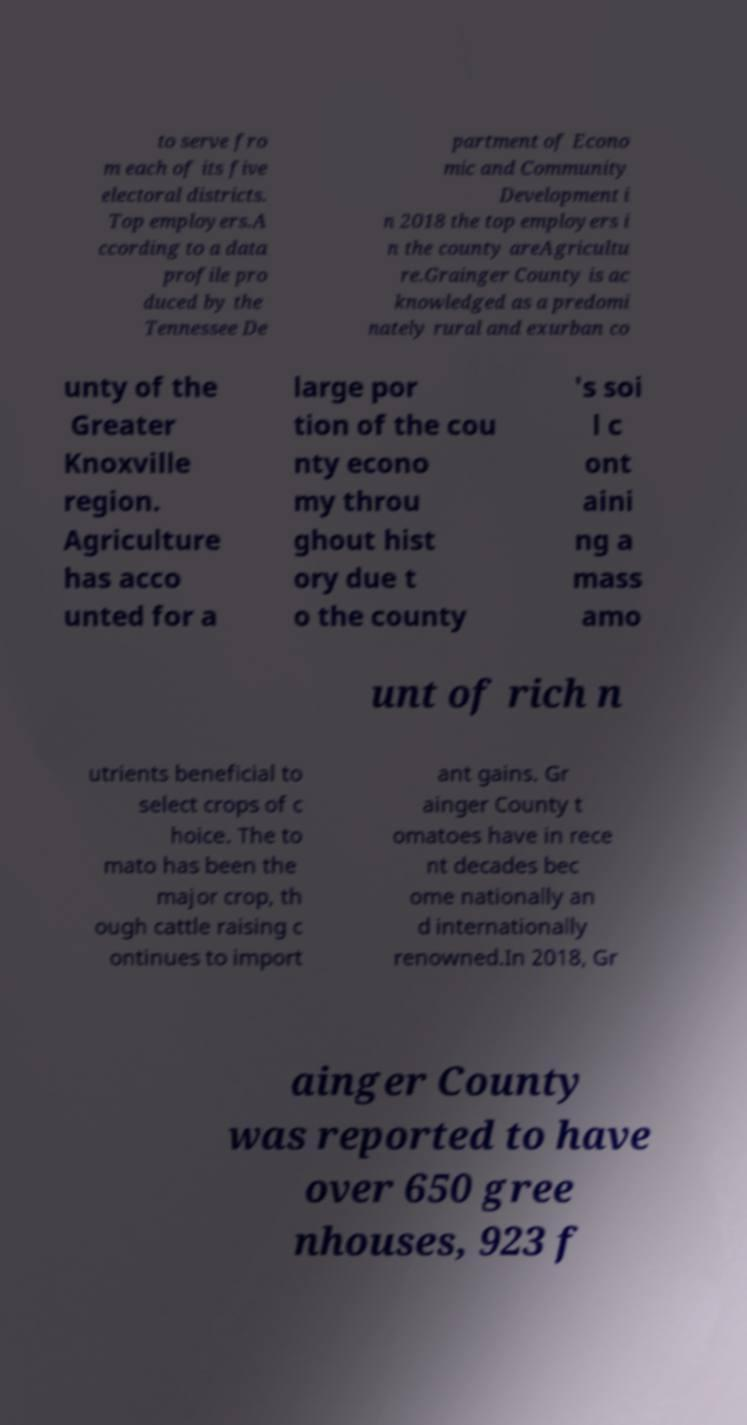For documentation purposes, I need the text within this image transcribed. Could you provide that? to serve fro m each of its five electoral districts. Top employers.A ccording to a data profile pro duced by the Tennessee De partment of Econo mic and Community Development i n 2018 the top employers i n the county areAgricultu re.Grainger County is ac knowledged as a predomi nately rural and exurban co unty of the Greater Knoxville region. Agriculture has acco unted for a large por tion of the cou nty econo my throu ghout hist ory due t o the county 's soi l c ont aini ng a mass amo unt of rich n utrients beneficial to select crops of c hoice. The to mato has been the major crop, th ough cattle raising c ontinues to import ant gains. Gr ainger County t omatoes have in rece nt decades bec ome nationally an d internationally renowned.In 2018, Gr ainger County was reported to have over 650 gree nhouses, 923 f 